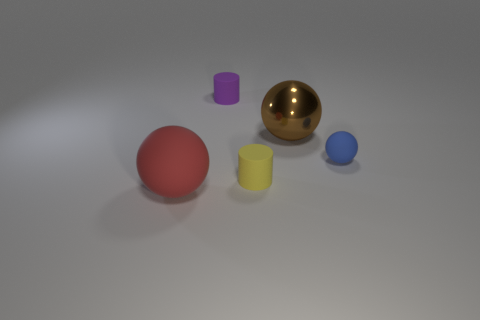Can you tell me the colors of the objects in the image, starting with the smallest object? The smallest object in the image is the blue sphere. Following that in ascending size are the purple cylinder, the yellow cylinder, the red sphere, and finally the largest object is the golden sphere. 